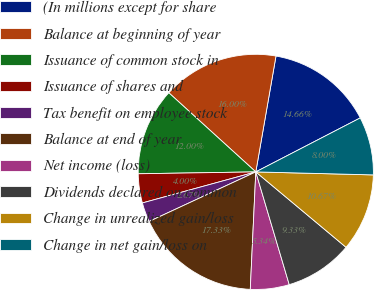Convert chart. <chart><loc_0><loc_0><loc_500><loc_500><pie_chart><fcel>(In millions except for share<fcel>Balance at beginning of year<fcel>Issuance of common stock in<fcel>Issuance of shares and<fcel>Tax benefit on employee stock<fcel>Balance at end of year<fcel>Net income (loss)<fcel>Dividends declared on common<fcel>Change in unrealized gain/loss<fcel>Change in net gain/loss on<nl><fcel>14.66%<fcel>16.0%<fcel>12.0%<fcel>4.0%<fcel>2.67%<fcel>17.33%<fcel>5.34%<fcel>9.33%<fcel>10.67%<fcel>8.0%<nl></chart> 